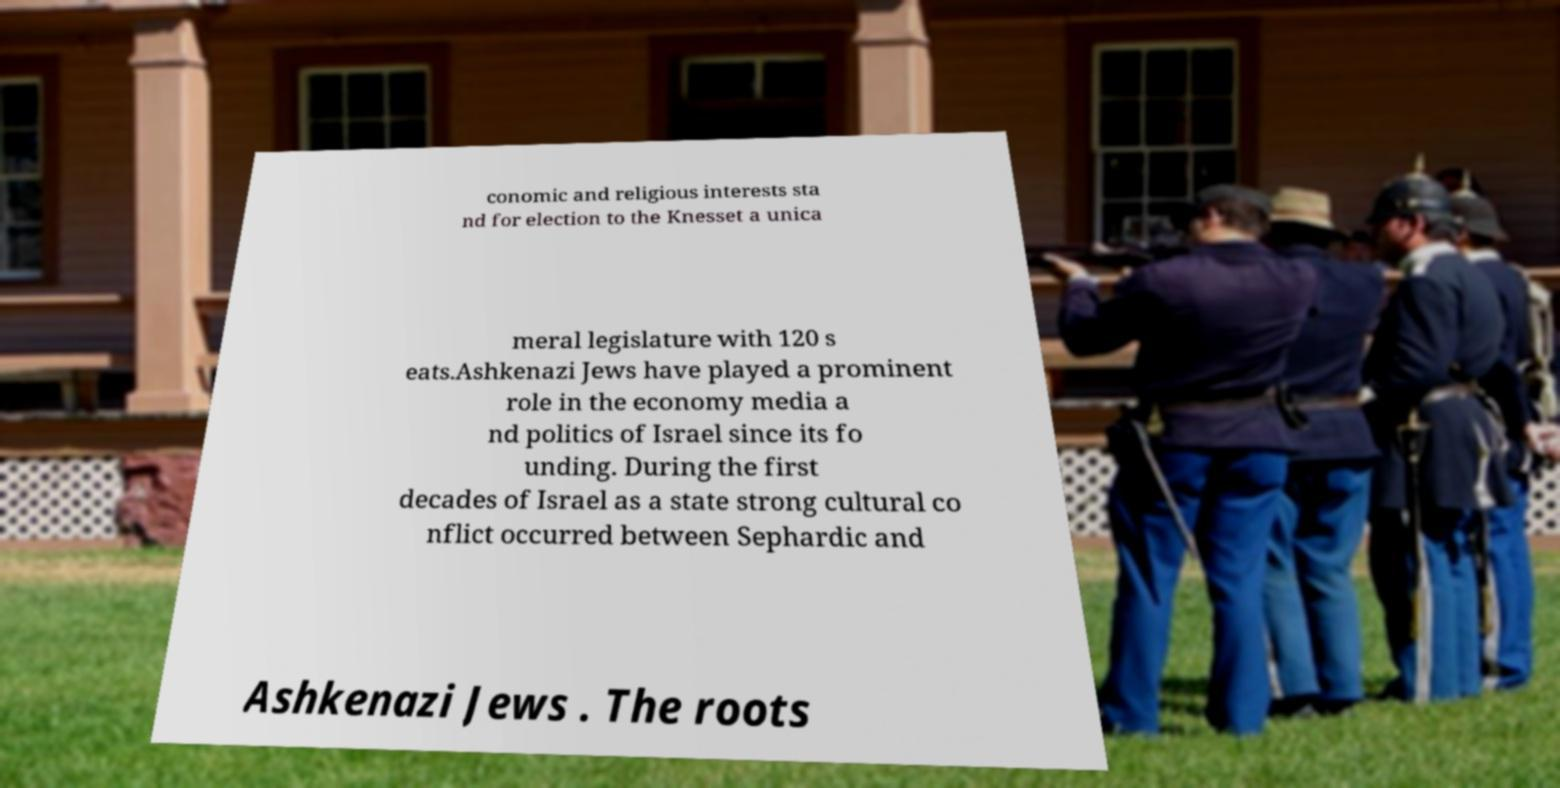What messages or text are displayed in this image? I need them in a readable, typed format. conomic and religious interests sta nd for election to the Knesset a unica meral legislature with 120 s eats.Ashkenazi Jews have played a prominent role in the economy media a nd politics of Israel since its fo unding. During the first decades of Israel as a state strong cultural co nflict occurred between Sephardic and Ashkenazi Jews . The roots 